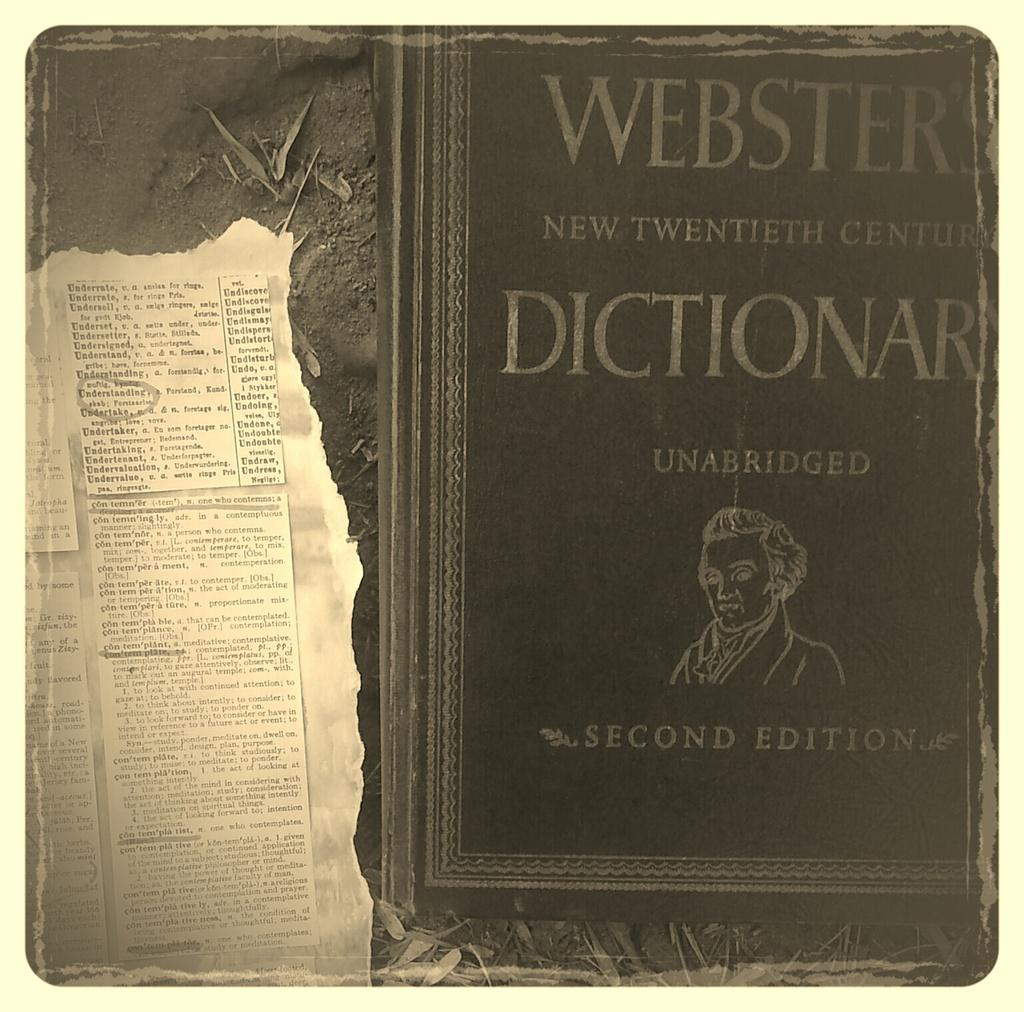<image>
Present a compact description of the photo's key features. A page was torn out of the old dictionary. 